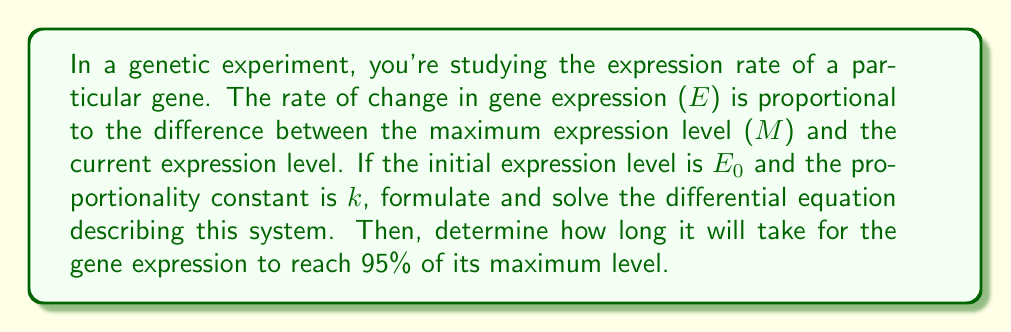Can you solve this math problem? Let's approach this step-by-step:

1) First, we need to formulate the differential equation. The rate of change in gene expression is given by:

   $$\frac{dE}{dt} = k(M - E)$$

   Where $E$ is the expression level, $t$ is time, $M$ is the maximum expression level, and $k$ is the proportionality constant.

2) This is a first-order linear differential equation. We can solve it using the separation of variables method:

   $$\frac{dE}{M - E} = k dt$$

3) Integrating both sides:

   $$-\ln|M - E| = kt + C$$

4) Using the initial condition $E = E_0$ at $t = 0$, we can find $C$:

   $$C = -\ln|M - E_0|$$

5) Substituting this back and simplifying:

   $$\ln|M - E| = \ln|M - E_0| - kt$$
   $$\frac{M - E}{M - E_0} = e^{-kt}$$
   $$E = M - (M - E_0)e^{-kt}$$

6) This is the general solution. To find the time when the expression reaches 95% of its maximum:

   $$0.95M = M - (M - E_0)e^{-kt}$$
   $$(M - E_0)e^{-kt} = 0.05M$$
   $$e^{-kt} = \frac{0.05M}{M - E_0}$$
   $$-kt = \ln(\frac{0.05M}{M - E_0})$$
   $$t = -\frac{1}{k}\ln(\frac{0.05M}{M - E_0})$$

This is the time it takes for the gene expression to reach 95% of its maximum level.
Answer: The differential equation describing the system is:

$$\frac{dE}{dt} = k(M - E)$$

The general solution is:

$$E = M - (M - E_0)e^{-kt}$$

The time to reach 95% of the maximum expression level is:

$$t = -\frac{1}{k}\ln(\frac{0.05M}{M - E_0})$$ 